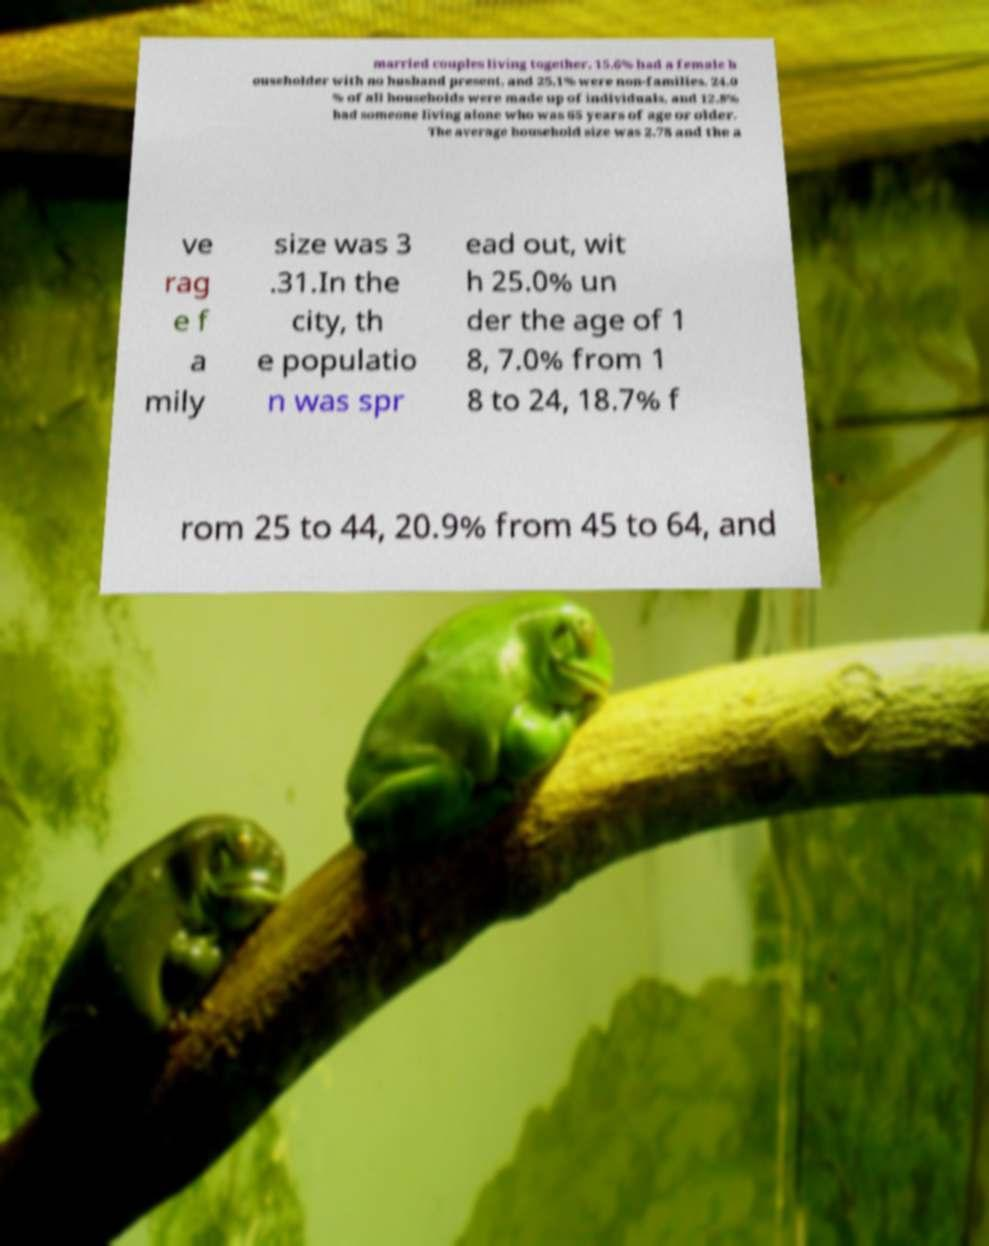For documentation purposes, I need the text within this image transcribed. Could you provide that? married couples living together, 15.6% had a female h ouseholder with no husband present, and 25.1% were non-families. 24.0 % of all households were made up of individuals, and 12.8% had someone living alone who was 65 years of age or older. The average household size was 2.78 and the a ve rag e f a mily size was 3 .31.In the city, th e populatio n was spr ead out, wit h 25.0% un der the age of 1 8, 7.0% from 1 8 to 24, 18.7% f rom 25 to 44, 20.9% from 45 to 64, and 